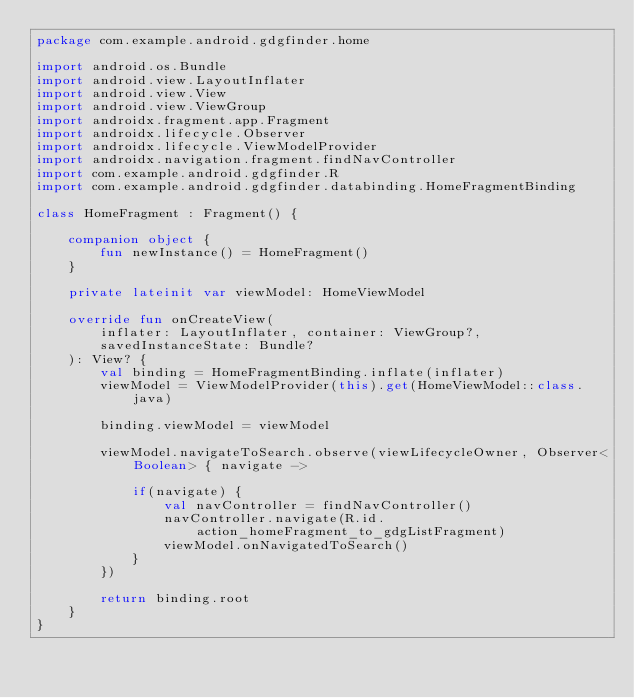<code> <loc_0><loc_0><loc_500><loc_500><_Kotlin_>package com.example.android.gdgfinder.home

import android.os.Bundle
import android.view.LayoutInflater
import android.view.View
import android.view.ViewGroup
import androidx.fragment.app.Fragment
import androidx.lifecycle.Observer
import androidx.lifecycle.ViewModelProvider
import androidx.navigation.fragment.findNavController
import com.example.android.gdgfinder.R
import com.example.android.gdgfinder.databinding.HomeFragmentBinding

class HomeFragment : Fragment() {

    companion object {
        fun newInstance() = HomeFragment()
    }

    private lateinit var viewModel: HomeViewModel

    override fun onCreateView(
        inflater: LayoutInflater, container: ViewGroup?,
        savedInstanceState: Bundle?
    ): View? {
        val binding = HomeFragmentBinding.inflate(inflater)
        viewModel = ViewModelProvider(this).get(HomeViewModel::class.java)

        binding.viewModel = viewModel

        viewModel.navigateToSearch.observe(viewLifecycleOwner, Observer<Boolean> { navigate ->

            if(navigate) {
                val navController = findNavController()
                navController.navigate(R.id.action_homeFragment_to_gdgListFragment)
                viewModel.onNavigatedToSearch()
            }
        })

        return binding.root
    }
}
</code> 